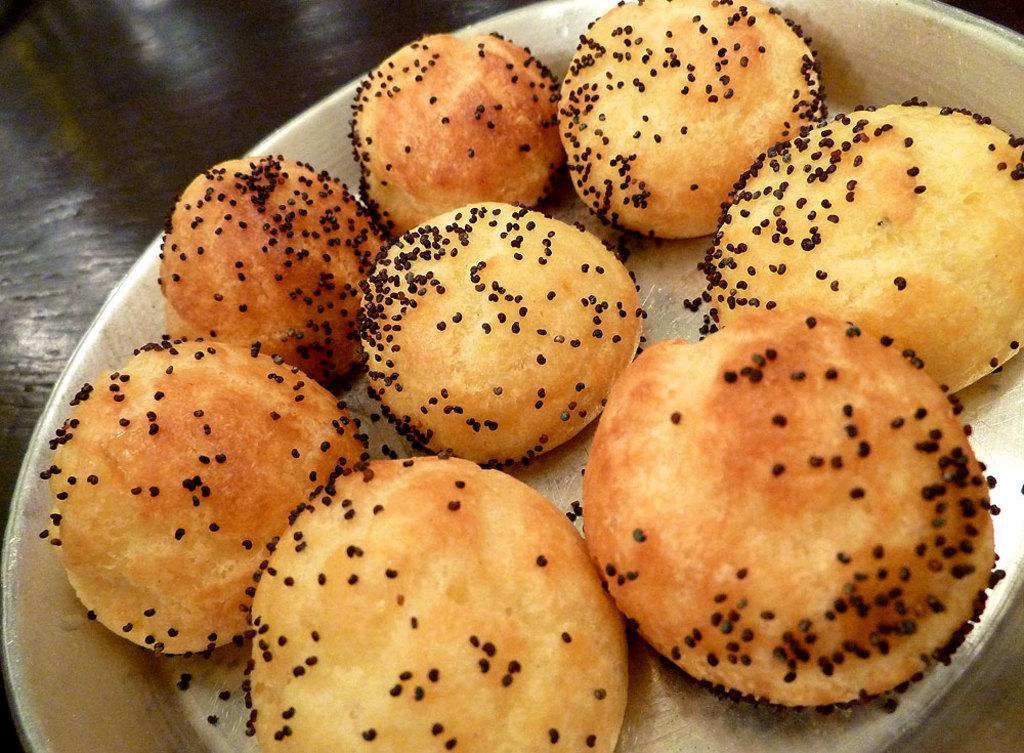Please provide a concise description of this image. In this image there is a plate having some food on it. Plate is kept on the table. 